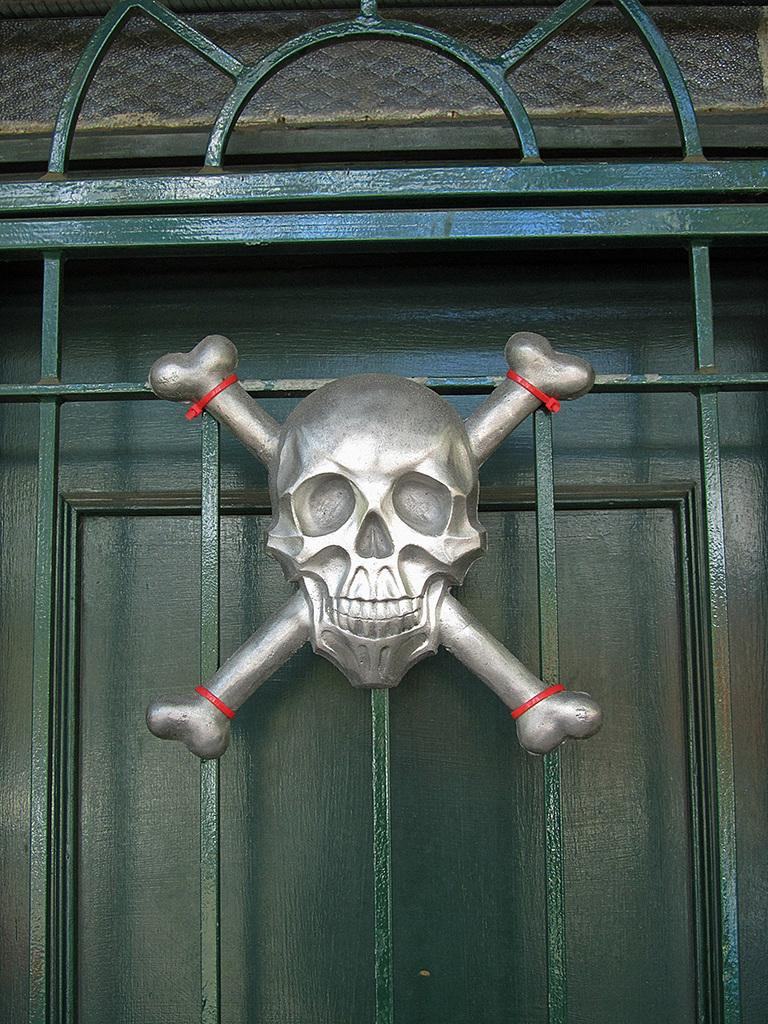What is the main object in the image? There is a skull object in the image. Where is the skull object located? The skull object is fixed to the window grill. What type of grain can be seen growing near the rod in the image? There is no rod or grain present in the image; it only features a skull object fixed to the window grill. 